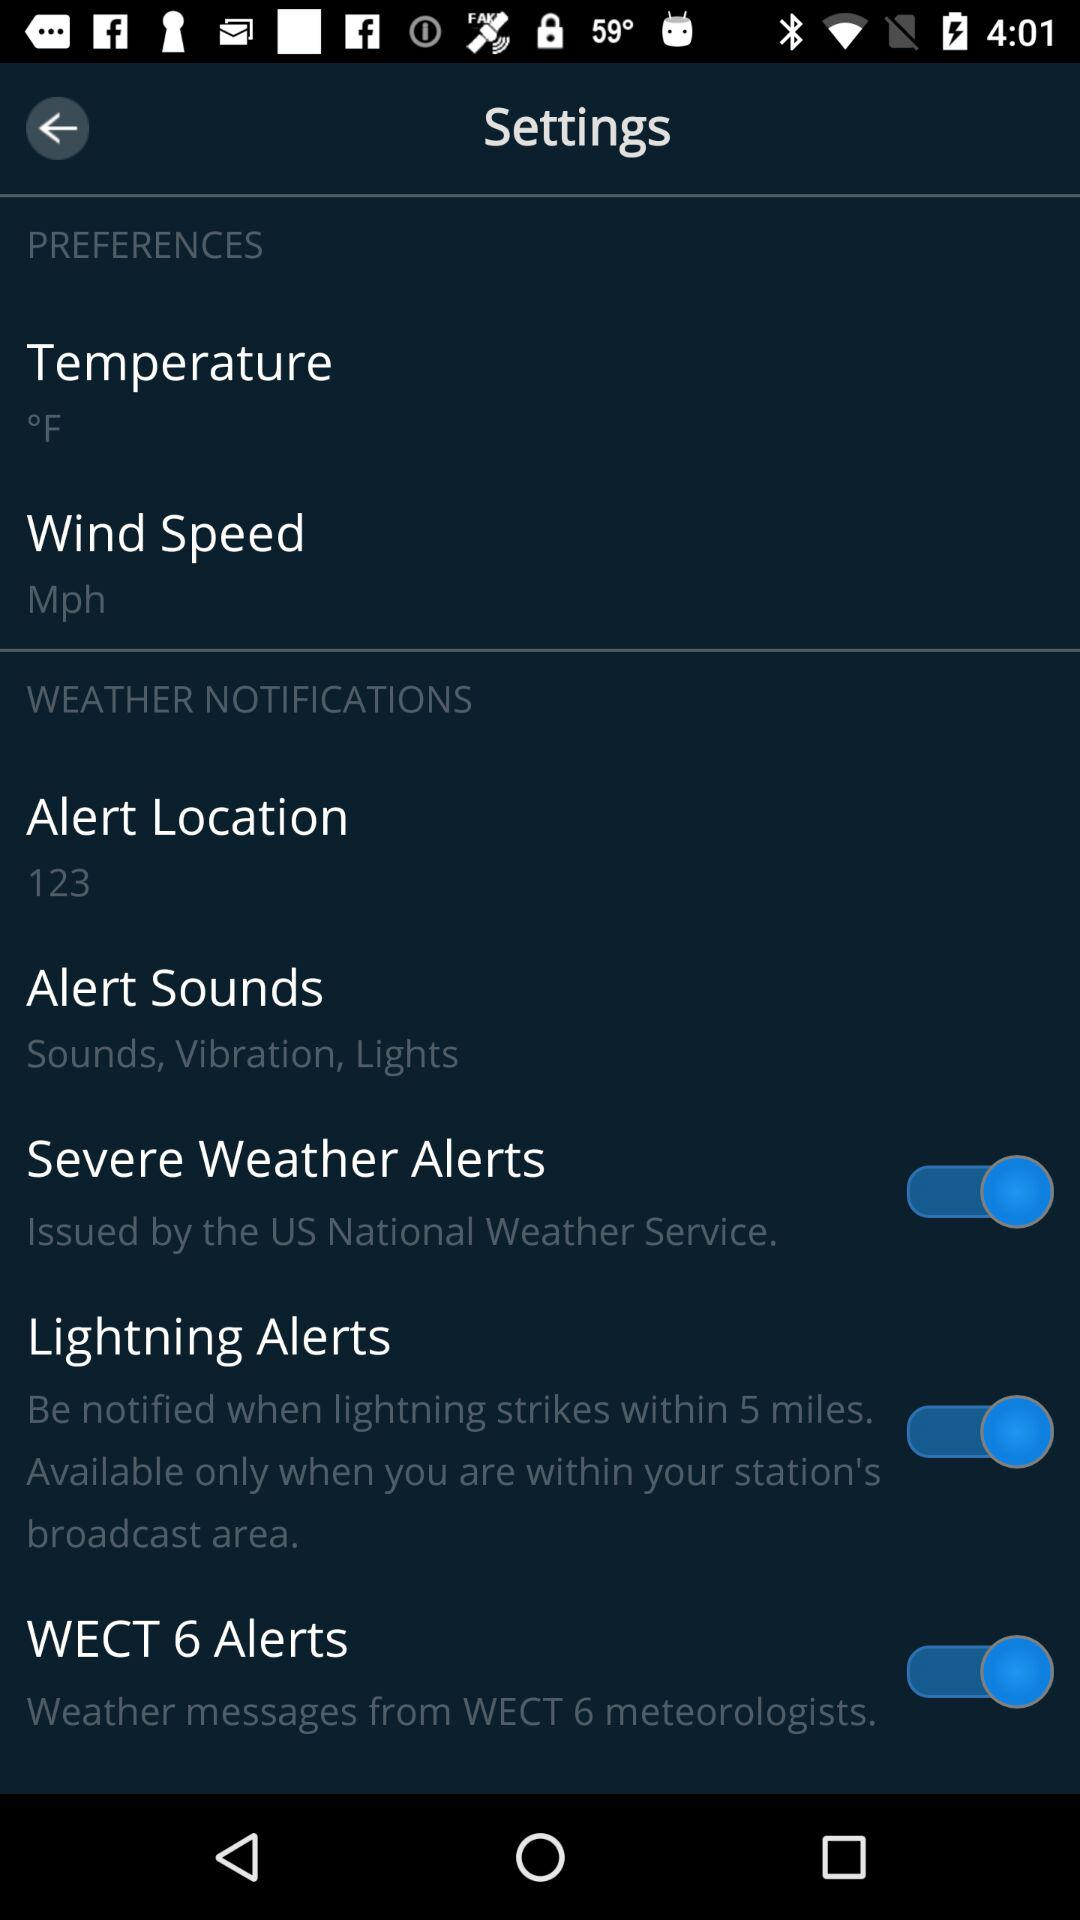Which number is mentioned in the "Alert Location"? The mentioned number is 123. 